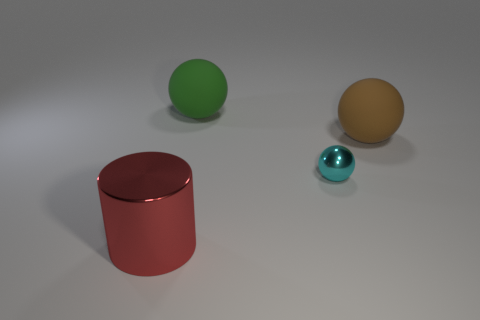What can you tell me about the lighting in the scene? The scene is softly lit with what appears to be diffuse overhead lighting, creating gentle shadows beneath the objects which suggests an indoor setting with either natural light from a cloudy sky or artificial light diffused by a lampshade or similar fixture. 